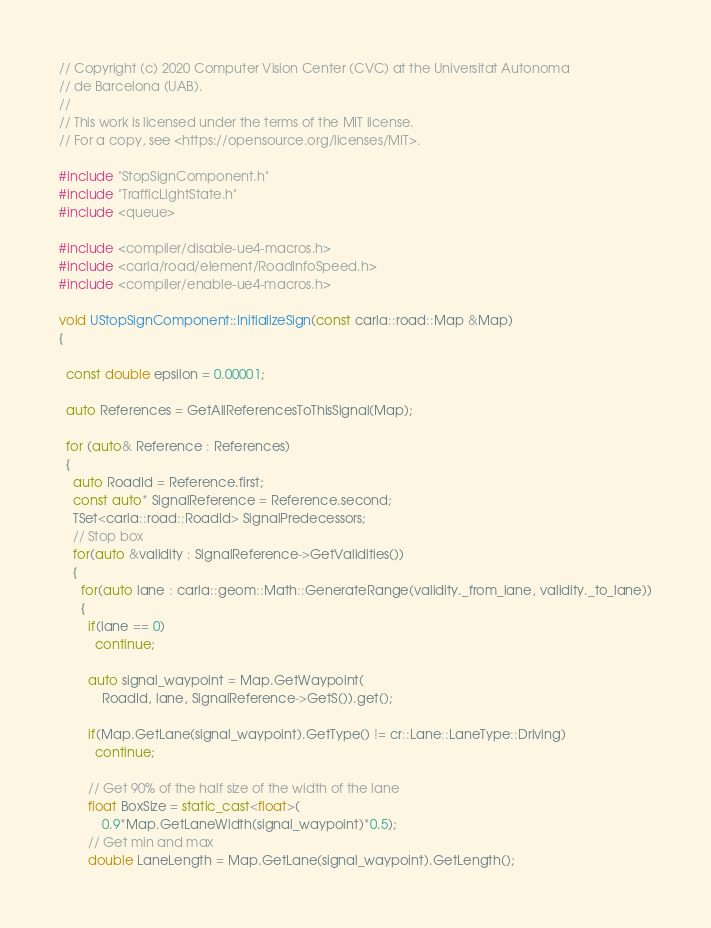Convert code to text. <code><loc_0><loc_0><loc_500><loc_500><_C++_>// Copyright (c) 2020 Computer Vision Center (CVC) at the Universitat Autonoma
// de Barcelona (UAB).
//
// This work is licensed under the terms of the MIT license.
// For a copy, see <https://opensource.org/licenses/MIT>.

#include "StopSignComponent.h"
#include "TrafficLightState.h"
#include <queue>

#include <compiler/disable-ue4-macros.h>
#include <carla/road/element/RoadInfoSpeed.h>
#include <compiler/enable-ue4-macros.h>

void UStopSignComponent::InitializeSign(const carla::road::Map &Map)
{

  const double epsilon = 0.00001;

  auto References = GetAllReferencesToThisSignal(Map);

  for (auto& Reference : References)
  {
    auto RoadId = Reference.first;
    const auto* SignalReference = Reference.second;
    TSet<carla::road::RoadId> SignalPredecessors;
    // Stop box
    for(auto &validity : SignalReference->GetValidities())
    {
      for(auto lane : carla::geom::Math::GenerateRange(validity._from_lane, validity._to_lane))
      {
        if(lane == 0)
          continue;

        auto signal_waypoint = Map.GetWaypoint(
            RoadId, lane, SignalReference->GetS()).get();

        if(Map.GetLane(signal_waypoint).GetType() != cr::Lane::LaneType::Driving)
          continue;

        // Get 90% of the half size of the width of the lane
        float BoxSize = static_cast<float>(
            0.9*Map.GetLaneWidth(signal_waypoint)*0.5);
        // Get min and max
        double LaneLength = Map.GetLane(signal_waypoint).GetLength();</code> 